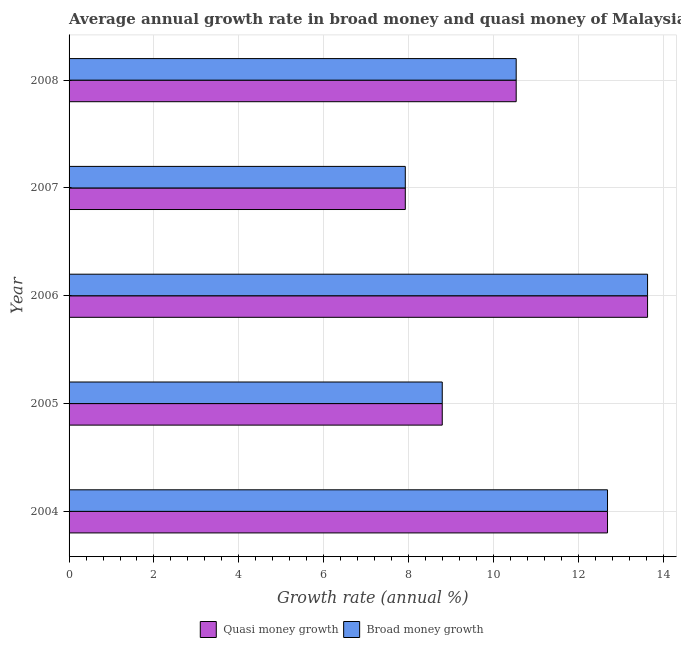How many groups of bars are there?
Offer a terse response. 5. Are the number of bars per tick equal to the number of legend labels?
Your response must be concise. Yes. Are the number of bars on each tick of the Y-axis equal?
Provide a succinct answer. Yes. How many bars are there on the 5th tick from the top?
Ensure brevity in your answer.  2. In how many cases, is the number of bars for a given year not equal to the number of legend labels?
Provide a short and direct response. 0. What is the annual growth rate in broad money in 2004?
Offer a very short reply. 12.69. Across all years, what is the maximum annual growth rate in broad money?
Ensure brevity in your answer.  13.63. Across all years, what is the minimum annual growth rate in broad money?
Your answer should be very brief. 7.92. In which year was the annual growth rate in broad money maximum?
Your answer should be very brief. 2006. In which year was the annual growth rate in quasi money minimum?
Give a very brief answer. 2007. What is the total annual growth rate in quasi money in the graph?
Your answer should be compact. 53.57. What is the difference between the annual growth rate in quasi money in 2005 and that in 2007?
Keep it short and to the point. 0.87. What is the difference between the annual growth rate in broad money in 2004 and the annual growth rate in quasi money in 2006?
Offer a very short reply. -0.94. What is the average annual growth rate in quasi money per year?
Your answer should be very brief. 10.71. What is the ratio of the annual growth rate in quasi money in 2004 to that in 2005?
Give a very brief answer. 1.44. What is the difference between the highest and the second highest annual growth rate in broad money?
Make the answer very short. 0.94. What is the difference between the highest and the lowest annual growth rate in quasi money?
Give a very brief answer. 5.71. Is the sum of the annual growth rate in broad money in 2005 and 2006 greater than the maximum annual growth rate in quasi money across all years?
Offer a terse response. Yes. What does the 2nd bar from the top in 2008 represents?
Provide a short and direct response. Quasi money growth. What does the 2nd bar from the bottom in 2007 represents?
Provide a succinct answer. Broad money growth. How many bars are there?
Provide a short and direct response. 10. Are all the bars in the graph horizontal?
Provide a succinct answer. Yes. How many years are there in the graph?
Ensure brevity in your answer.  5. What is the difference between two consecutive major ticks on the X-axis?
Provide a succinct answer. 2. Are the values on the major ticks of X-axis written in scientific E-notation?
Keep it short and to the point. No. How are the legend labels stacked?
Make the answer very short. Horizontal. What is the title of the graph?
Offer a very short reply. Average annual growth rate in broad money and quasi money of Malaysia. What is the label or title of the X-axis?
Ensure brevity in your answer.  Growth rate (annual %). What is the label or title of the Y-axis?
Offer a very short reply. Year. What is the Growth rate (annual %) of Quasi money growth in 2004?
Your answer should be very brief. 12.69. What is the Growth rate (annual %) of Broad money growth in 2004?
Provide a short and direct response. 12.69. What is the Growth rate (annual %) in Quasi money growth in 2005?
Offer a very short reply. 8.79. What is the Growth rate (annual %) of Broad money growth in 2005?
Make the answer very short. 8.79. What is the Growth rate (annual %) of Quasi money growth in 2006?
Keep it short and to the point. 13.63. What is the Growth rate (annual %) of Broad money growth in 2006?
Offer a terse response. 13.63. What is the Growth rate (annual %) in Quasi money growth in 2007?
Keep it short and to the point. 7.92. What is the Growth rate (annual %) of Broad money growth in 2007?
Keep it short and to the point. 7.92. What is the Growth rate (annual %) of Quasi money growth in 2008?
Offer a terse response. 10.54. What is the Growth rate (annual %) in Broad money growth in 2008?
Your answer should be very brief. 10.54. Across all years, what is the maximum Growth rate (annual %) of Quasi money growth?
Your answer should be compact. 13.63. Across all years, what is the maximum Growth rate (annual %) in Broad money growth?
Offer a terse response. 13.63. Across all years, what is the minimum Growth rate (annual %) in Quasi money growth?
Your response must be concise. 7.92. Across all years, what is the minimum Growth rate (annual %) of Broad money growth?
Provide a succinct answer. 7.92. What is the total Growth rate (annual %) in Quasi money growth in the graph?
Make the answer very short. 53.57. What is the total Growth rate (annual %) of Broad money growth in the graph?
Keep it short and to the point. 53.57. What is the difference between the Growth rate (annual %) of Quasi money growth in 2004 and that in 2005?
Offer a very short reply. 3.89. What is the difference between the Growth rate (annual %) of Broad money growth in 2004 and that in 2005?
Ensure brevity in your answer.  3.89. What is the difference between the Growth rate (annual %) in Quasi money growth in 2004 and that in 2006?
Your response must be concise. -0.94. What is the difference between the Growth rate (annual %) of Broad money growth in 2004 and that in 2006?
Keep it short and to the point. -0.94. What is the difference between the Growth rate (annual %) of Quasi money growth in 2004 and that in 2007?
Your response must be concise. 4.76. What is the difference between the Growth rate (annual %) of Broad money growth in 2004 and that in 2007?
Provide a short and direct response. 4.76. What is the difference between the Growth rate (annual %) in Quasi money growth in 2004 and that in 2008?
Your answer should be compact. 2.15. What is the difference between the Growth rate (annual %) in Broad money growth in 2004 and that in 2008?
Give a very brief answer. 2.15. What is the difference between the Growth rate (annual %) of Quasi money growth in 2005 and that in 2006?
Your answer should be compact. -4.84. What is the difference between the Growth rate (annual %) of Broad money growth in 2005 and that in 2006?
Offer a very short reply. -4.84. What is the difference between the Growth rate (annual %) of Quasi money growth in 2005 and that in 2007?
Offer a terse response. 0.87. What is the difference between the Growth rate (annual %) in Broad money growth in 2005 and that in 2007?
Make the answer very short. 0.87. What is the difference between the Growth rate (annual %) of Quasi money growth in 2005 and that in 2008?
Your response must be concise. -1.74. What is the difference between the Growth rate (annual %) in Broad money growth in 2005 and that in 2008?
Offer a terse response. -1.74. What is the difference between the Growth rate (annual %) in Quasi money growth in 2006 and that in 2007?
Provide a short and direct response. 5.71. What is the difference between the Growth rate (annual %) in Broad money growth in 2006 and that in 2007?
Offer a terse response. 5.71. What is the difference between the Growth rate (annual %) of Quasi money growth in 2006 and that in 2008?
Offer a terse response. 3.1. What is the difference between the Growth rate (annual %) in Broad money growth in 2006 and that in 2008?
Provide a short and direct response. 3.1. What is the difference between the Growth rate (annual %) of Quasi money growth in 2007 and that in 2008?
Provide a succinct answer. -2.61. What is the difference between the Growth rate (annual %) of Broad money growth in 2007 and that in 2008?
Keep it short and to the point. -2.61. What is the difference between the Growth rate (annual %) of Quasi money growth in 2004 and the Growth rate (annual %) of Broad money growth in 2005?
Make the answer very short. 3.89. What is the difference between the Growth rate (annual %) in Quasi money growth in 2004 and the Growth rate (annual %) in Broad money growth in 2006?
Your response must be concise. -0.94. What is the difference between the Growth rate (annual %) in Quasi money growth in 2004 and the Growth rate (annual %) in Broad money growth in 2007?
Your answer should be very brief. 4.76. What is the difference between the Growth rate (annual %) in Quasi money growth in 2004 and the Growth rate (annual %) in Broad money growth in 2008?
Your answer should be compact. 2.15. What is the difference between the Growth rate (annual %) of Quasi money growth in 2005 and the Growth rate (annual %) of Broad money growth in 2006?
Make the answer very short. -4.84. What is the difference between the Growth rate (annual %) of Quasi money growth in 2005 and the Growth rate (annual %) of Broad money growth in 2007?
Provide a succinct answer. 0.87. What is the difference between the Growth rate (annual %) of Quasi money growth in 2005 and the Growth rate (annual %) of Broad money growth in 2008?
Make the answer very short. -1.74. What is the difference between the Growth rate (annual %) in Quasi money growth in 2006 and the Growth rate (annual %) in Broad money growth in 2007?
Keep it short and to the point. 5.71. What is the difference between the Growth rate (annual %) in Quasi money growth in 2006 and the Growth rate (annual %) in Broad money growth in 2008?
Ensure brevity in your answer.  3.1. What is the difference between the Growth rate (annual %) of Quasi money growth in 2007 and the Growth rate (annual %) of Broad money growth in 2008?
Offer a terse response. -2.61. What is the average Growth rate (annual %) of Quasi money growth per year?
Your response must be concise. 10.71. What is the average Growth rate (annual %) of Broad money growth per year?
Your answer should be very brief. 10.71. In the year 2004, what is the difference between the Growth rate (annual %) of Quasi money growth and Growth rate (annual %) of Broad money growth?
Your answer should be very brief. 0. In the year 2005, what is the difference between the Growth rate (annual %) in Quasi money growth and Growth rate (annual %) in Broad money growth?
Your response must be concise. 0. What is the ratio of the Growth rate (annual %) of Quasi money growth in 2004 to that in 2005?
Your answer should be very brief. 1.44. What is the ratio of the Growth rate (annual %) in Broad money growth in 2004 to that in 2005?
Your response must be concise. 1.44. What is the ratio of the Growth rate (annual %) of Quasi money growth in 2004 to that in 2006?
Offer a very short reply. 0.93. What is the ratio of the Growth rate (annual %) in Broad money growth in 2004 to that in 2006?
Give a very brief answer. 0.93. What is the ratio of the Growth rate (annual %) in Quasi money growth in 2004 to that in 2007?
Provide a short and direct response. 1.6. What is the ratio of the Growth rate (annual %) of Broad money growth in 2004 to that in 2007?
Your response must be concise. 1.6. What is the ratio of the Growth rate (annual %) in Quasi money growth in 2004 to that in 2008?
Make the answer very short. 1.2. What is the ratio of the Growth rate (annual %) in Broad money growth in 2004 to that in 2008?
Offer a very short reply. 1.2. What is the ratio of the Growth rate (annual %) of Quasi money growth in 2005 to that in 2006?
Make the answer very short. 0.65. What is the ratio of the Growth rate (annual %) in Broad money growth in 2005 to that in 2006?
Make the answer very short. 0.65. What is the ratio of the Growth rate (annual %) of Quasi money growth in 2005 to that in 2007?
Give a very brief answer. 1.11. What is the ratio of the Growth rate (annual %) of Broad money growth in 2005 to that in 2007?
Keep it short and to the point. 1.11. What is the ratio of the Growth rate (annual %) in Quasi money growth in 2005 to that in 2008?
Provide a short and direct response. 0.83. What is the ratio of the Growth rate (annual %) in Broad money growth in 2005 to that in 2008?
Offer a very short reply. 0.83. What is the ratio of the Growth rate (annual %) of Quasi money growth in 2006 to that in 2007?
Ensure brevity in your answer.  1.72. What is the ratio of the Growth rate (annual %) in Broad money growth in 2006 to that in 2007?
Your answer should be very brief. 1.72. What is the ratio of the Growth rate (annual %) in Quasi money growth in 2006 to that in 2008?
Provide a succinct answer. 1.29. What is the ratio of the Growth rate (annual %) in Broad money growth in 2006 to that in 2008?
Provide a succinct answer. 1.29. What is the ratio of the Growth rate (annual %) in Quasi money growth in 2007 to that in 2008?
Provide a short and direct response. 0.75. What is the ratio of the Growth rate (annual %) of Broad money growth in 2007 to that in 2008?
Give a very brief answer. 0.75. What is the difference between the highest and the second highest Growth rate (annual %) of Quasi money growth?
Your answer should be very brief. 0.94. What is the difference between the highest and the second highest Growth rate (annual %) in Broad money growth?
Your answer should be very brief. 0.94. What is the difference between the highest and the lowest Growth rate (annual %) of Quasi money growth?
Offer a very short reply. 5.71. What is the difference between the highest and the lowest Growth rate (annual %) in Broad money growth?
Provide a succinct answer. 5.71. 